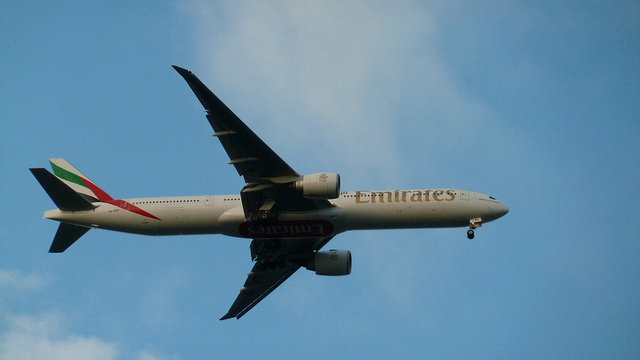Identify the text displayed in this image. Emuates 